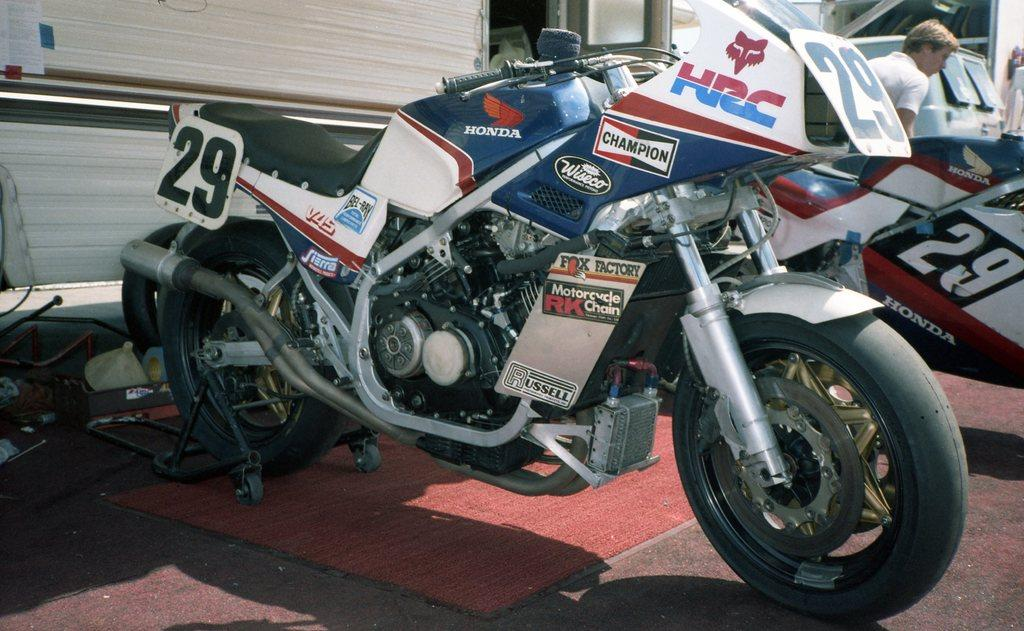What type of vehicles are in the image? There are bikes in the image. What material are the rods made of in the image? The rods in the image are made of metal. Can you describe the person on the right side of the image? There is a man on the right side of the image. How many clovers can be seen growing near the bikes in the image? There are no clovers visible in the image; it features bikes and metal rods. What type of weather condition is present in the image due to the presence of fog? There is no mention of fog in the image; it only features bikes, metal rods, and a man. 